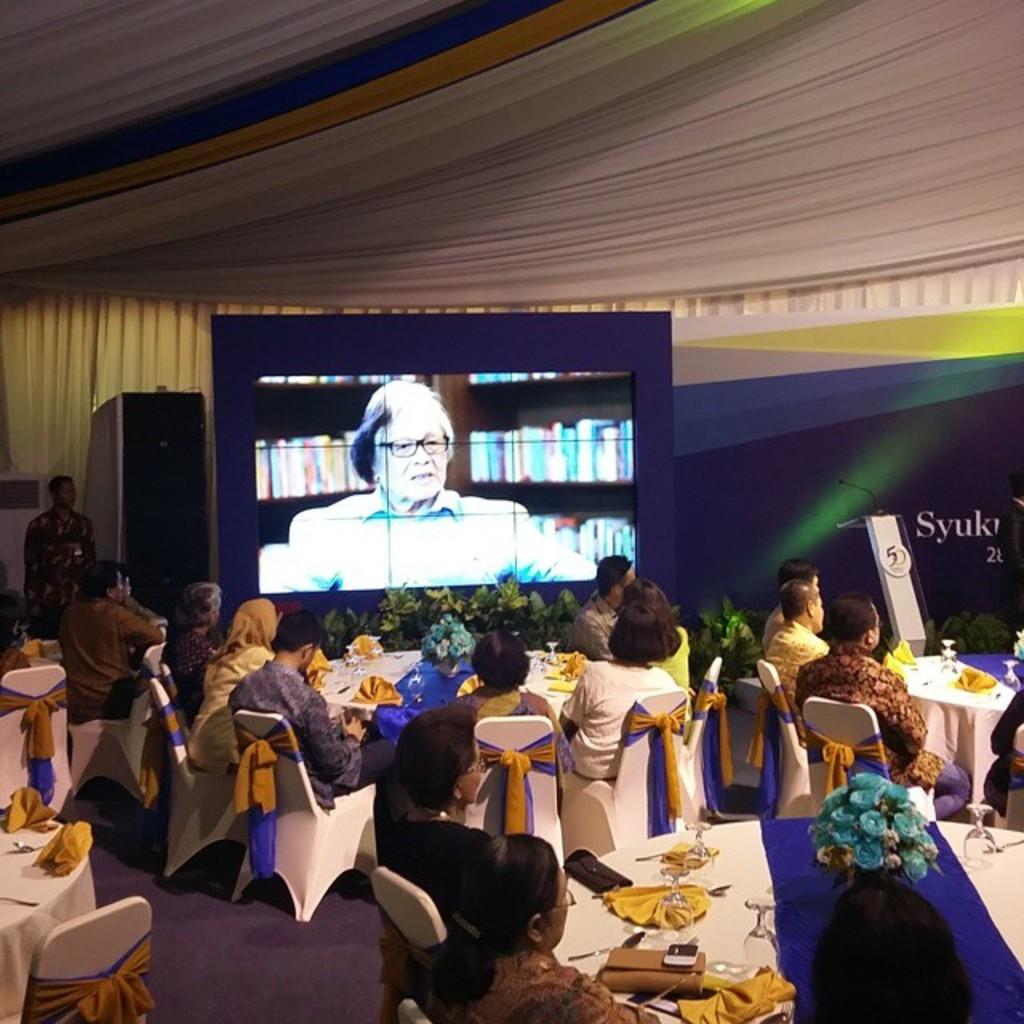Describe this image in one or two sentences. In this picture we can see some people are sitting on the chair in front of them there is a table on the table we have tissues, wallets, phones and some flower was and back side we can see screen on that one women speaking in front of the screen there are some potted plants. 